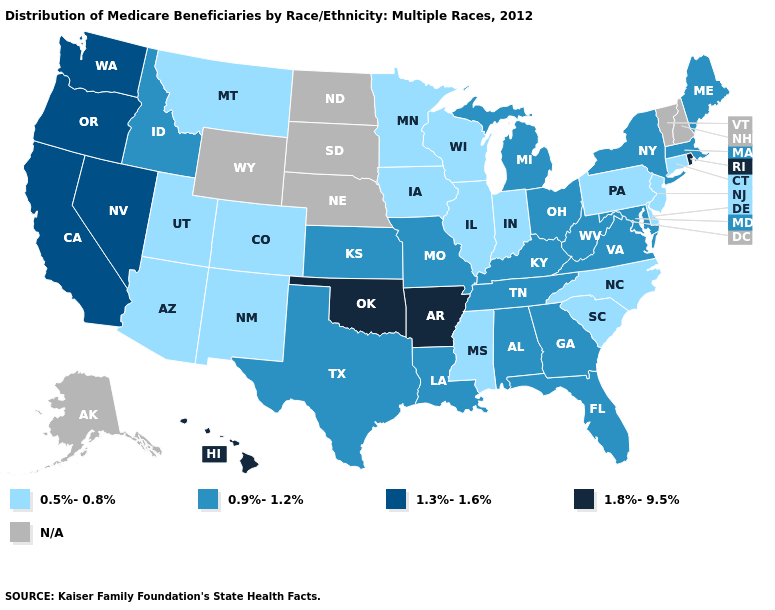What is the lowest value in the USA?
Write a very short answer. 0.5%-0.8%. Which states have the lowest value in the USA?
Keep it brief. Arizona, Colorado, Connecticut, Delaware, Illinois, Indiana, Iowa, Minnesota, Mississippi, Montana, New Jersey, New Mexico, North Carolina, Pennsylvania, South Carolina, Utah, Wisconsin. How many symbols are there in the legend?
Concise answer only. 5. Name the states that have a value in the range 1.8%-9.5%?
Keep it brief. Arkansas, Hawaii, Oklahoma, Rhode Island. What is the value of Montana?
Be succinct. 0.5%-0.8%. What is the lowest value in the USA?
Write a very short answer. 0.5%-0.8%. What is the lowest value in the USA?
Write a very short answer. 0.5%-0.8%. Name the states that have a value in the range N/A?
Answer briefly. Alaska, Nebraska, New Hampshire, North Dakota, South Dakota, Vermont, Wyoming. Is the legend a continuous bar?
Keep it brief. No. Name the states that have a value in the range 0.9%-1.2%?
Write a very short answer. Alabama, Florida, Georgia, Idaho, Kansas, Kentucky, Louisiana, Maine, Maryland, Massachusetts, Michigan, Missouri, New York, Ohio, Tennessee, Texas, Virginia, West Virginia. Name the states that have a value in the range 0.5%-0.8%?
Short answer required. Arizona, Colorado, Connecticut, Delaware, Illinois, Indiana, Iowa, Minnesota, Mississippi, Montana, New Jersey, New Mexico, North Carolina, Pennsylvania, South Carolina, Utah, Wisconsin. 